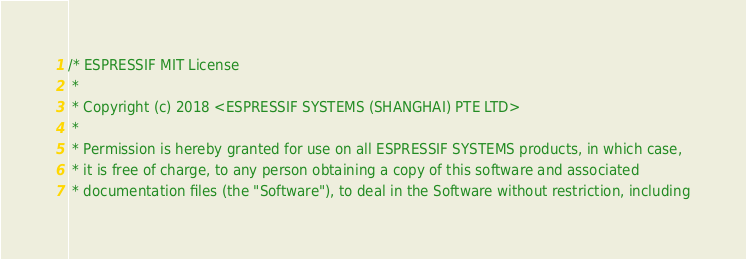Convert code to text. <code><loc_0><loc_0><loc_500><loc_500><_C_>/* ESPRESSIF MIT License
 *
 * Copyright (c) 2018 <ESPRESSIF SYSTEMS (SHANGHAI) PTE LTD>
 *
 * Permission is hereby granted for use on all ESPRESSIF SYSTEMS products, in which case,
 * it is free of charge, to any person obtaining a copy of this software and associated
 * documentation files (the "Software"), to deal in the Software without restriction, including</code> 